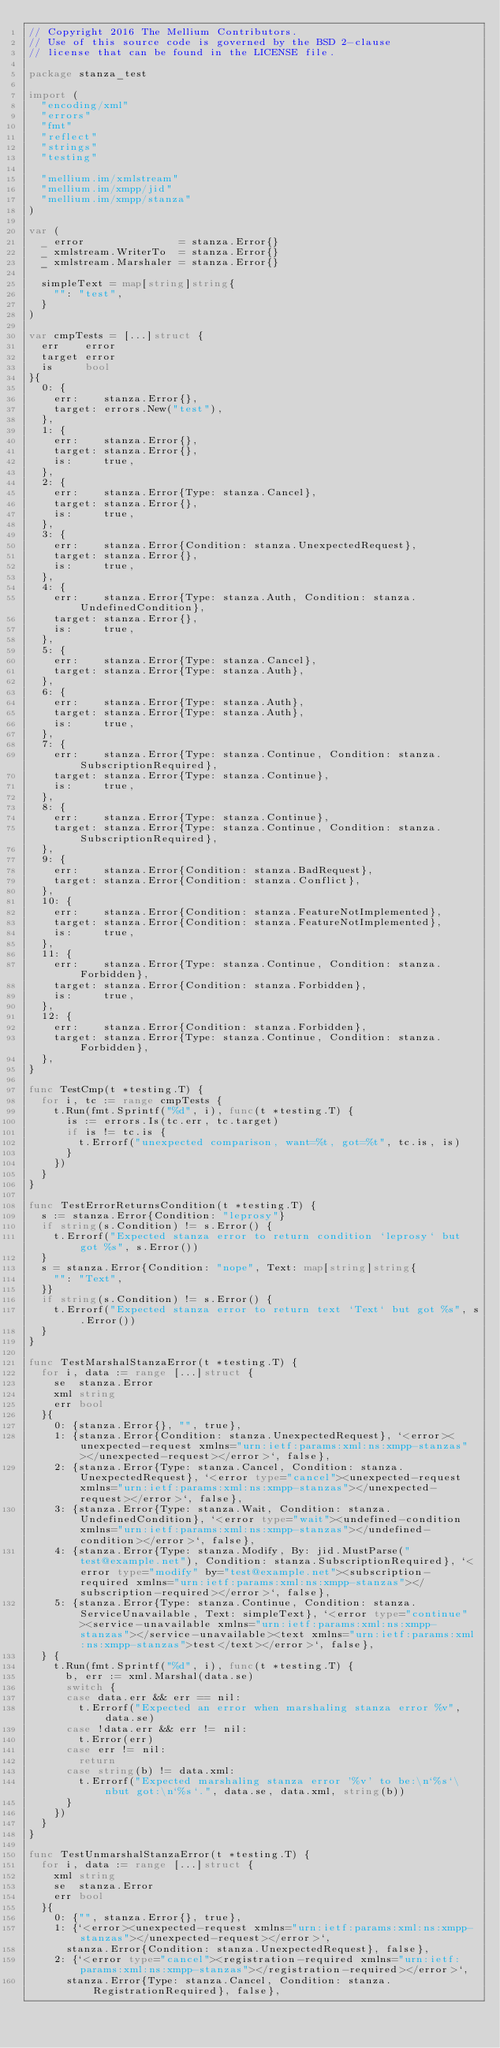Convert code to text. <code><loc_0><loc_0><loc_500><loc_500><_Go_>// Copyright 2016 The Mellium Contributors.
// Use of this source code is governed by the BSD 2-clause
// license that can be found in the LICENSE file.

package stanza_test

import (
	"encoding/xml"
	"errors"
	"fmt"
	"reflect"
	"strings"
	"testing"

	"mellium.im/xmlstream"
	"mellium.im/xmpp/jid"
	"mellium.im/xmpp/stanza"
)

var (
	_ error               = stanza.Error{}
	_ xmlstream.WriterTo  = stanza.Error{}
	_ xmlstream.Marshaler = stanza.Error{}

	simpleText = map[string]string{
		"": "test",
	}
)

var cmpTests = [...]struct {
	err    error
	target error
	is     bool
}{
	0: {
		err:    stanza.Error{},
		target: errors.New("test"),
	},
	1: {
		err:    stanza.Error{},
		target: stanza.Error{},
		is:     true,
	},
	2: {
		err:    stanza.Error{Type: stanza.Cancel},
		target: stanza.Error{},
		is:     true,
	},
	3: {
		err:    stanza.Error{Condition: stanza.UnexpectedRequest},
		target: stanza.Error{},
		is:     true,
	},
	4: {
		err:    stanza.Error{Type: stanza.Auth, Condition: stanza.UndefinedCondition},
		target: stanza.Error{},
		is:     true,
	},
	5: {
		err:    stanza.Error{Type: stanza.Cancel},
		target: stanza.Error{Type: stanza.Auth},
	},
	6: {
		err:    stanza.Error{Type: stanza.Auth},
		target: stanza.Error{Type: stanza.Auth},
		is:     true,
	},
	7: {
		err:    stanza.Error{Type: stanza.Continue, Condition: stanza.SubscriptionRequired},
		target: stanza.Error{Type: stanza.Continue},
		is:     true,
	},
	8: {
		err:    stanza.Error{Type: stanza.Continue},
		target: stanza.Error{Type: stanza.Continue, Condition: stanza.SubscriptionRequired},
	},
	9: {
		err:    stanza.Error{Condition: stanza.BadRequest},
		target: stanza.Error{Condition: stanza.Conflict},
	},
	10: {
		err:    stanza.Error{Condition: stanza.FeatureNotImplemented},
		target: stanza.Error{Condition: stanza.FeatureNotImplemented},
		is:     true,
	},
	11: {
		err:    stanza.Error{Type: stanza.Continue, Condition: stanza.Forbidden},
		target: stanza.Error{Condition: stanza.Forbidden},
		is:     true,
	},
	12: {
		err:    stanza.Error{Condition: stanza.Forbidden},
		target: stanza.Error{Type: stanza.Continue, Condition: stanza.Forbidden},
	},
}

func TestCmp(t *testing.T) {
	for i, tc := range cmpTests {
		t.Run(fmt.Sprintf("%d", i), func(t *testing.T) {
			is := errors.Is(tc.err, tc.target)
			if is != tc.is {
				t.Errorf("unexpected comparison, want=%t, got=%t", tc.is, is)
			}
		})
	}
}

func TestErrorReturnsCondition(t *testing.T) {
	s := stanza.Error{Condition: "leprosy"}
	if string(s.Condition) != s.Error() {
		t.Errorf("Expected stanza error to return condition `leprosy` but got %s", s.Error())
	}
	s = stanza.Error{Condition: "nope", Text: map[string]string{
		"": "Text",
	}}
	if string(s.Condition) != s.Error() {
		t.Errorf("Expected stanza error to return text `Text` but got %s", s.Error())
	}
}

func TestMarshalStanzaError(t *testing.T) {
	for i, data := range [...]struct {
		se  stanza.Error
		xml string
		err bool
	}{
		0: {stanza.Error{}, "", true},
		1: {stanza.Error{Condition: stanza.UnexpectedRequest}, `<error><unexpected-request xmlns="urn:ietf:params:xml:ns:xmpp-stanzas"></unexpected-request></error>`, false},
		2: {stanza.Error{Type: stanza.Cancel, Condition: stanza.UnexpectedRequest}, `<error type="cancel"><unexpected-request xmlns="urn:ietf:params:xml:ns:xmpp-stanzas"></unexpected-request></error>`, false},
		3: {stanza.Error{Type: stanza.Wait, Condition: stanza.UndefinedCondition}, `<error type="wait"><undefined-condition xmlns="urn:ietf:params:xml:ns:xmpp-stanzas"></undefined-condition></error>`, false},
		4: {stanza.Error{Type: stanza.Modify, By: jid.MustParse("test@example.net"), Condition: stanza.SubscriptionRequired}, `<error type="modify" by="test@example.net"><subscription-required xmlns="urn:ietf:params:xml:ns:xmpp-stanzas"></subscription-required></error>`, false},
		5: {stanza.Error{Type: stanza.Continue, Condition: stanza.ServiceUnavailable, Text: simpleText}, `<error type="continue"><service-unavailable xmlns="urn:ietf:params:xml:ns:xmpp-stanzas"></service-unavailable><text xmlns="urn:ietf:params:xml:ns:xmpp-stanzas">test</text></error>`, false},
	} {
		t.Run(fmt.Sprintf("%d", i), func(t *testing.T) {
			b, err := xml.Marshal(data.se)
			switch {
			case data.err && err == nil:
				t.Errorf("Expected an error when marshaling stanza error %v", data.se)
			case !data.err && err != nil:
				t.Error(err)
			case err != nil:
				return
			case string(b) != data.xml:
				t.Errorf("Expected marshaling stanza error '%v' to be:\n`%s`\nbut got:\n`%s`.", data.se, data.xml, string(b))
			}
		})
	}
}

func TestUnmarshalStanzaError(t *testing.T) {
	for i, data := range [...]struct {
		xml string
		se  stanza.Error
		err bool
	}{
		0: {"", stanza.Error{}, true},
		1: {`<error><unexpected-request xmlns="urn:ietf:params:xml:ns:xmpp-stanzas"></unexpected-request></error>`,
			stanza.Error{Condition: stanza.UnexpectedRequest}, false},
		2: {`<error type="cancel"><registration-required xmlns="urn:ietf:params:xml:ns:xmpp-stanzas"></registration-required></error>`,
			stanza.Error{Type: stanza.Cancel, Condition: stanza.RegistrationRequired}, false},</code> 